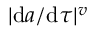Convert formula to latex. <formula><loc_0><loc_0><loc_500><loc_500>| d a / d \tau | ^ { v }</formula> 